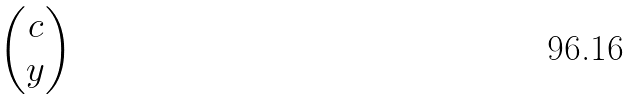Convert formula to latex. <formula><loc_0><loc_0><loc_500><loc_500>\begin{pmatrix} c \\ y \end{pmatrix}</formula> 